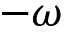<formula> <loc_0><loc_0><loc_500><loc_500>- \omega</formula> 